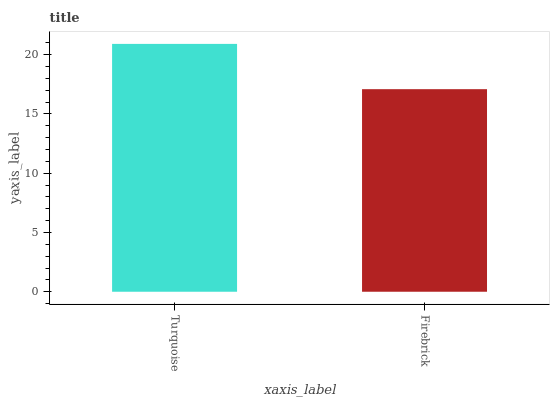Is Firebrick the minimum?
Answer yes or no. Yes. Is Turquoise the maximum?
Answer yes or no. Yes. Is Firebrick the maximum?
Answer yes or no. No. Is Turquoise greater than Firebrick?
Answer yes or no. Yes. Is Firebrick less than Turquoise?
Answer yes or no. Yes. Is Firebrick greater than Turquoise?
Answer yes or no. No. Is Turquoise less than Firebrick?
Answer yes or no. No. Is Turquoise the high median?
Answer yes or no. Yes. Is Firebrick the low median?
Answer yes or no. Yes. Is Firebrick the high median?
Answer yes or no. No. Is Turquoise the low median?
Answer yes or no. No. 